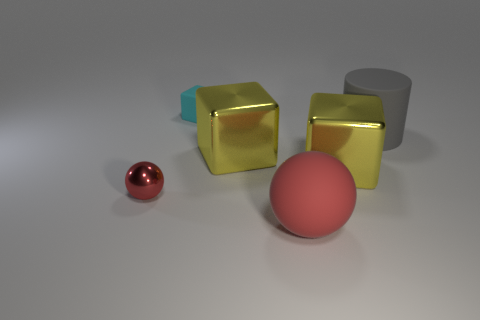Is the tiny sphere made of the same material as the cyan object?
Your response must be concise. No. There is a matte object on the right side of the red ball right of the large metal object that is left of the rubber sphere; what shape is it?
Offer a terse response. Cylinder. Is the number of gray rubber cylinders left of the big gray matte object less than the number of large matte objects that are behind the tiny cyan matte thing?
Your response must be concise. No. There is a red thing left of the small object behind the large gray cylinder; what is its shape?
Provide a short and direct response. Sphere. Are there any other things that have the same color as the big ball?
Provide a short and direct response. Yes. Does the big rubber ball have the same color as the matte cube?
Make the answer very short. No. What number of purple things are either cylinders or big shiny things?
Give a very brief answer. 0. Is the number of tiny things on the left side of the tiny metallic thing less than the number of big red rubber balls?
Make the answer very short. Yes. There is a small object in front of the large gray thing; what number of shiny objects are behind it?
Your answer should be very brief. 2. What number of other objects are the same size as the gray matte thing?
Make the answer very short. 3. 